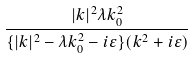<formula> <loc_0><loc_0><loc_500><loc_500>\frac { | k | ^ { 2 } \lambda k _ { 0 } ^ { 2 } } { \{ | k | ^ { 2 } - \lambda k _ { 0 } ^ { 2 } - i \varepsilon \} ( k ^ { 2 } + i \varepsilon ) }</formula> 